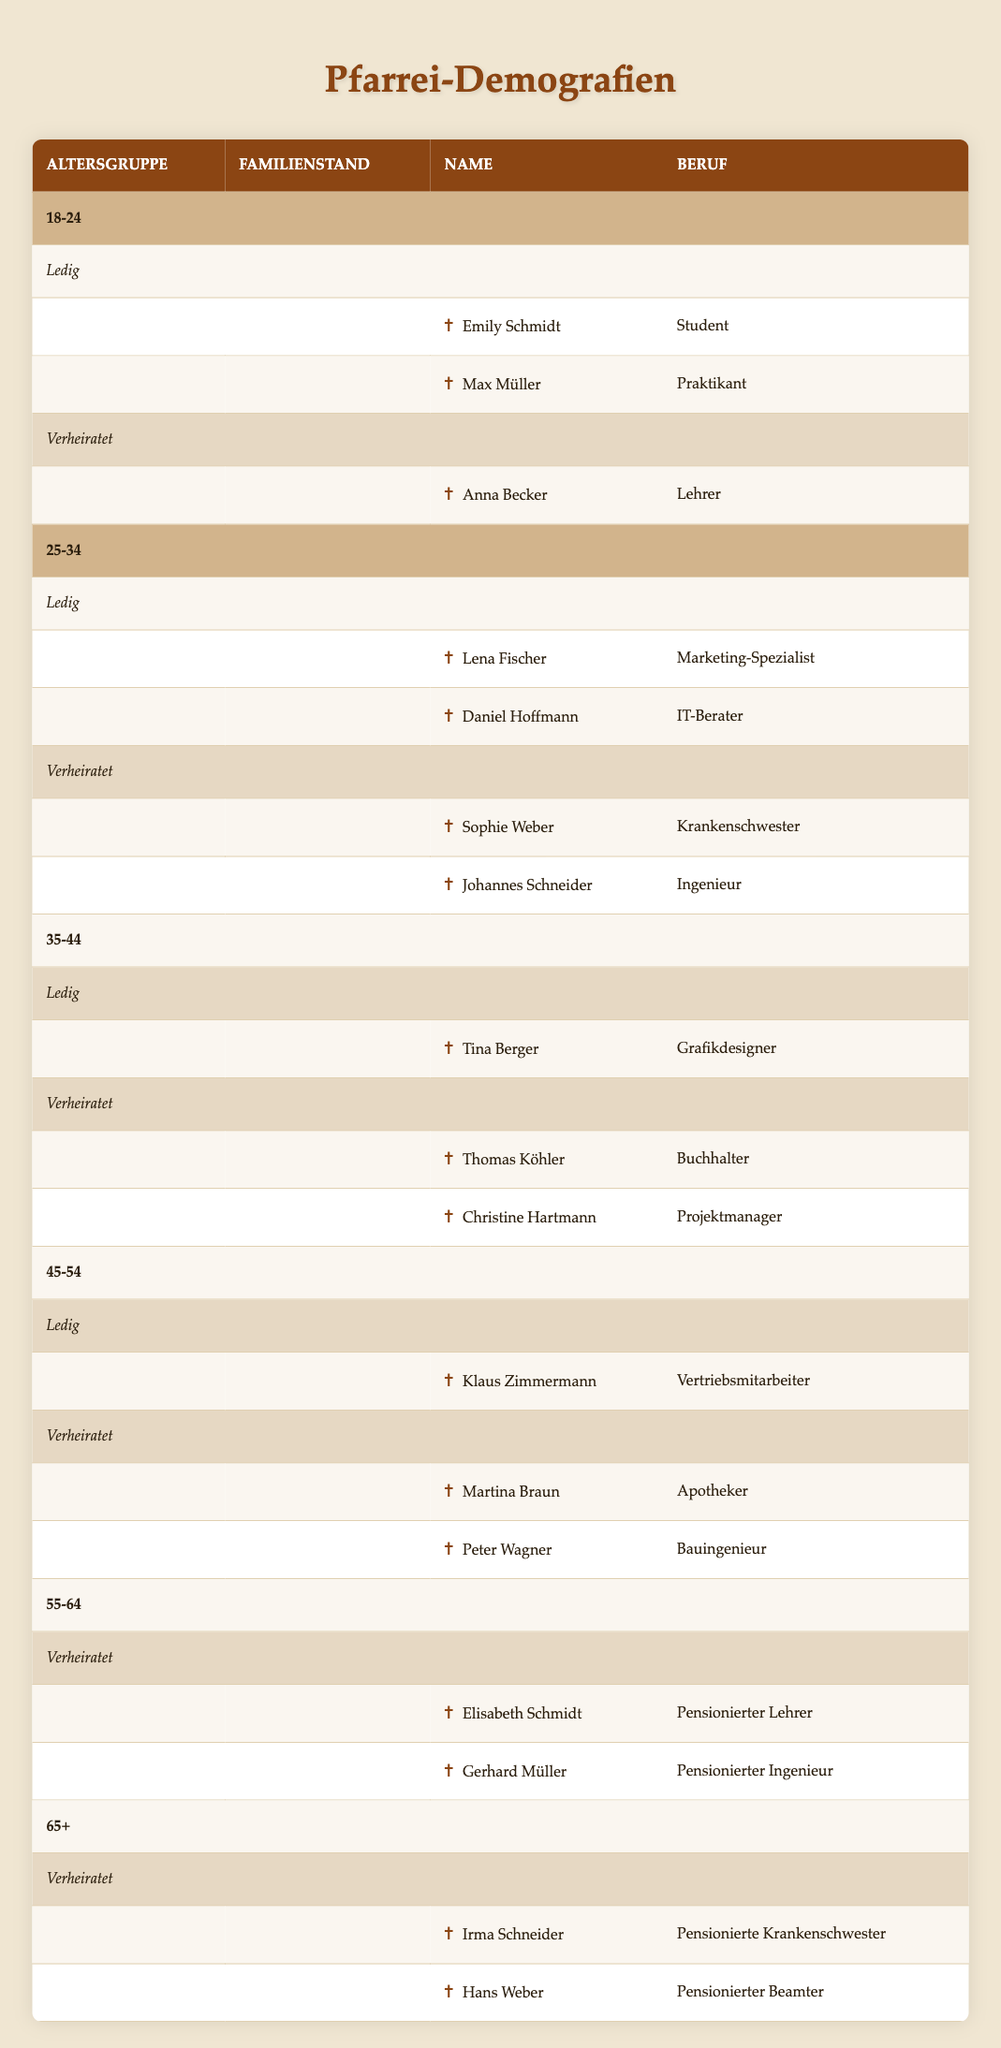What are the names of all single parishioners aged 18-24? The table lists the age group 18-24, and under marital status "Single," there are two names: Emily Schmidt and Max Müller.
Answer: Emily Schmidt, Max Müller How many married parishioners are there in the age group 25-34? In the age group 25-34, under the "Married" category, there are two parishioners: Sophie Weber and Johannes Schneider. Adding these gives a total of 2.
Answer: 2 Is there any single parishioner in the age group 55-64? Referencing the age group 55-64, it shows that there are no parishioners listed under the "Single" category. Thus, the answer is no.
Answer: No What is the total number of parishioners aged 45-54? To find the total for the age group 45-54, we count one single parishioner (Klaus Zimmermann) and two married parishioners (Martina Braun and Peter Wagner), giving a total of 3 parishioners.
Answer: 3 What is the occupation of the oldest married parishioner? The oldest age group is 65+, and under "Married," we have Irma Schneider (Retired Nurse) and Hans Weber (Retired Civil Servant). The oldest among them is not distinctly mentioned by age, but both are retired. Thus, we list both occupations.
Answer: Retired Nurse, Retired Civil Servant How many single parishioners are there across all age groups? The table shows single parishioners in age groups 18-24 (2), 25-34 (2), 35-44 (1), and 45-54 (1). Adding these together: 2 + 2 + 1 + 1 = 6.
Answer: 6 Are there any parishioners aged 55-64 who are single? In the age group 55-64, there are no parishioners listed under "Single," confirming that the answer is no.
Answer: No Which age group has the highest number of married parishioners? The age group 25-34 has 2 married parishioners, and the age group 35-44 has another 2. The age group 45-54 also has 2 married parishioners. However, age groups 55-64 and 65+ each have only 2 married parishioners, but no age group exceeds this. The highest count remains at 2.
Answer: 25-34, 35-44, 45-54 (tie) 